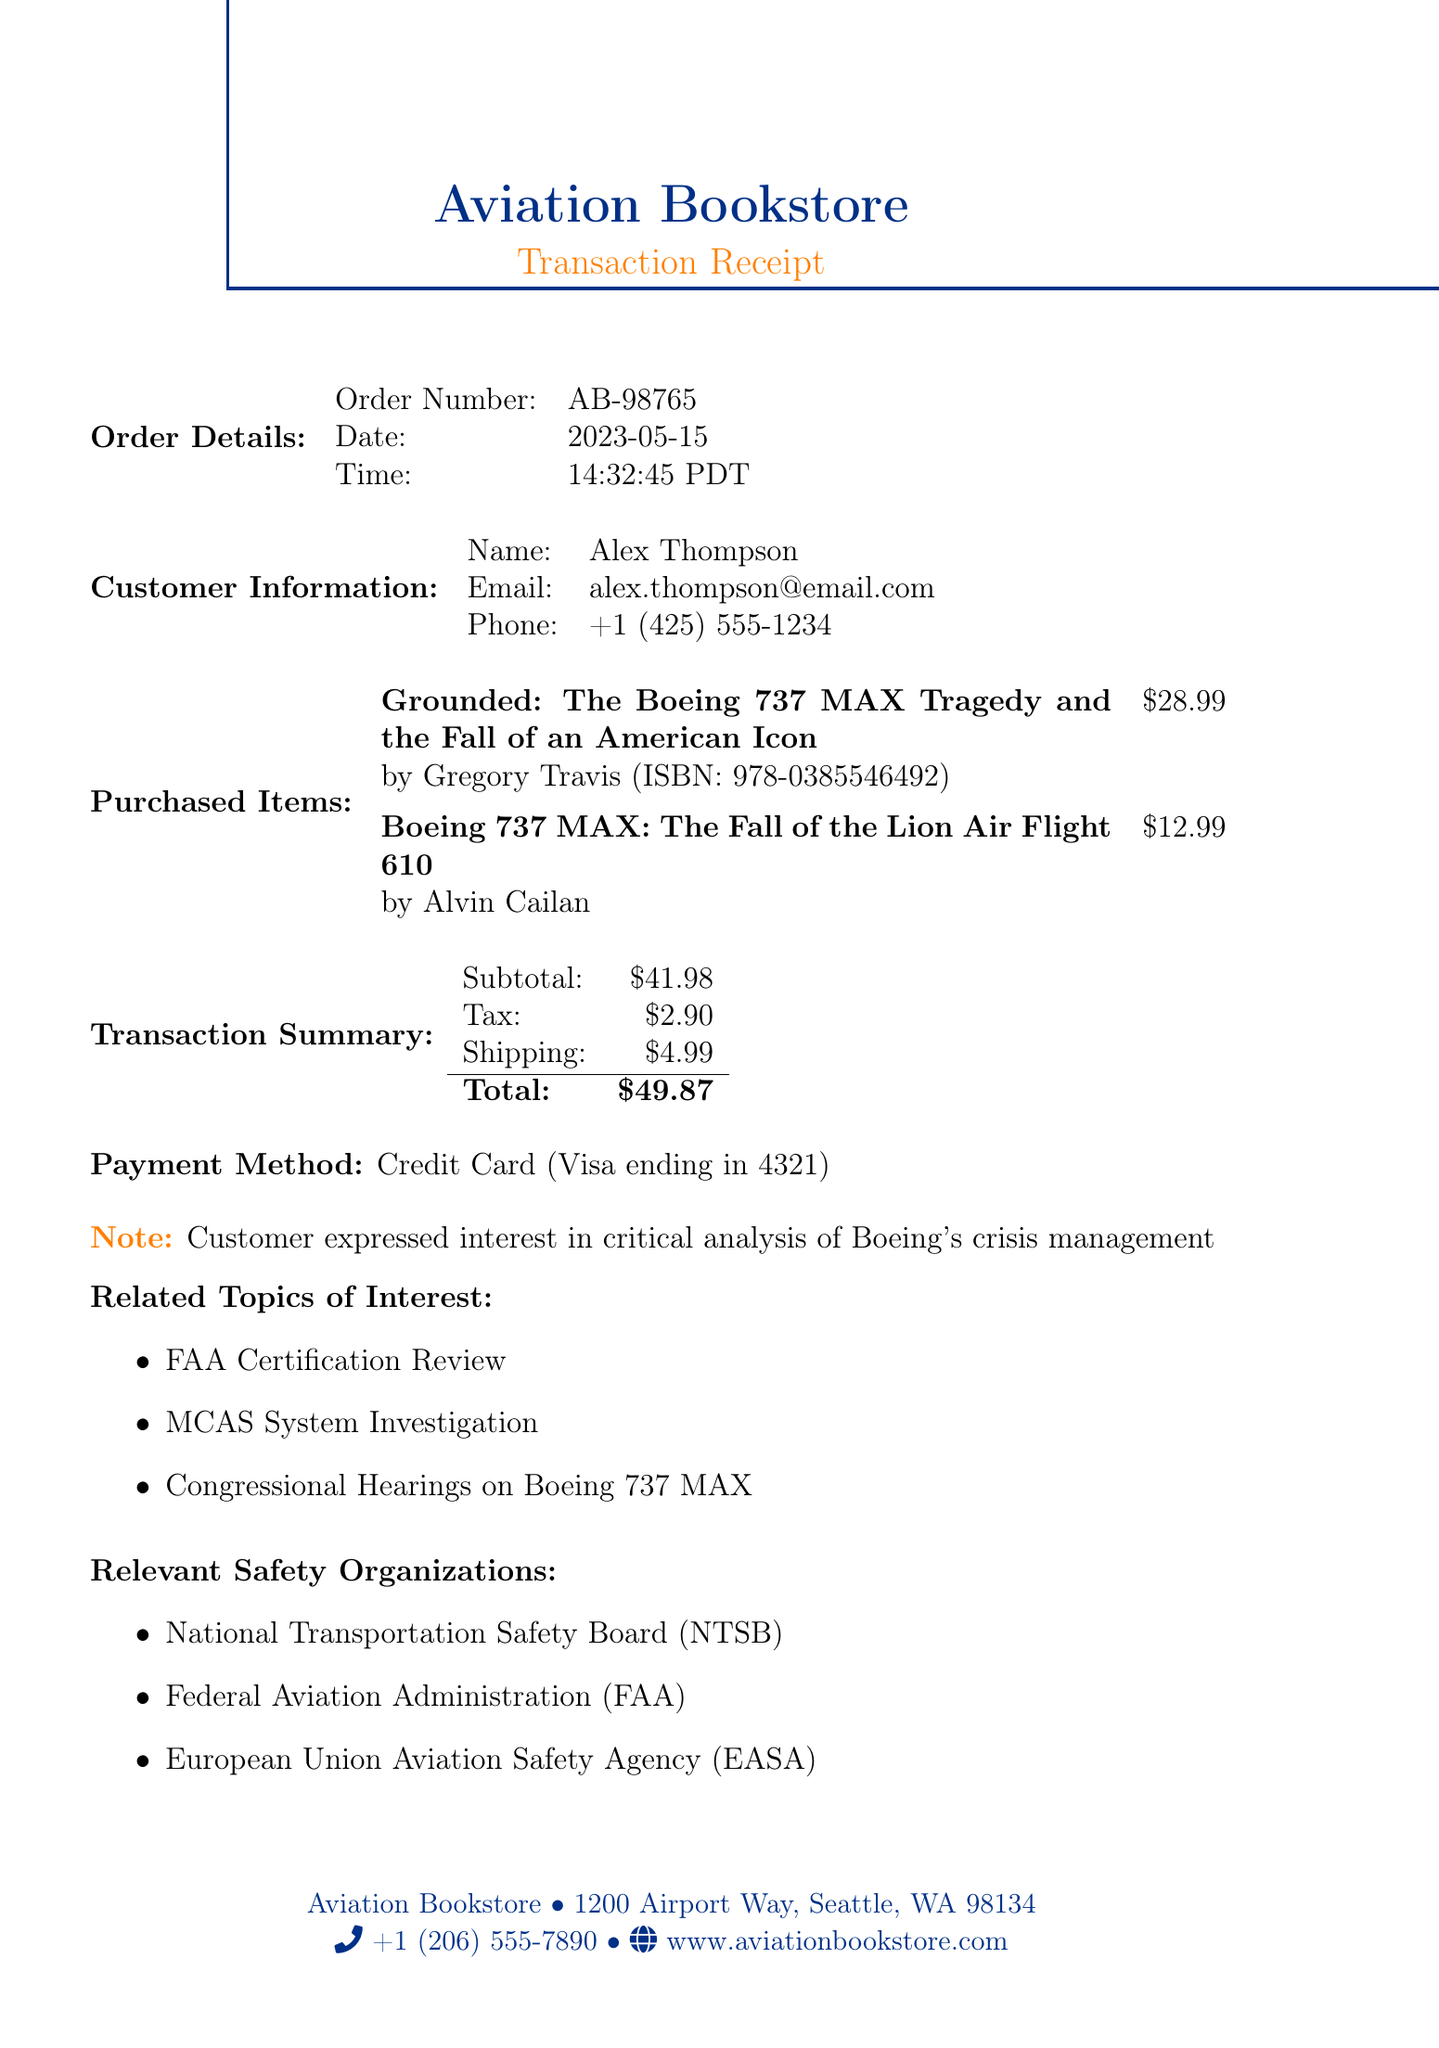What is the title of the purchased book? The title of the purchased book is stated in the document under book details.
Answer: Grounded: The Boeing 737 MAX Tragedy and the Fall of an American Icon Who is the author of the book? The author's name is provided alongside the book title in the document.
Answer: Gregory Travis What is the total amount paid for the transaction? The total amount is clearly listed in the transaction summary of the document.
Answer: $36.88 What is the order number associated with this purchase? The order number is mentioned in the order details section of the document.
Answer: AB-98765 What note did the customer express? The document contains a note section highlighting the customer's interest.
Answer: Customer expressed interest in critical analysis of Boeing's crisis management How much was charged for shipping? The shipping cost is detailed in the transaction summary section of the document.
Answer: $4.99 What was the payment method used for this transaction? The payment method is explicitly stated in the transaction summary of the document.
Answer: Credit Card (Visa ending in 4321) Name one related event mentioned in the document. The document lists several related events that are significant to the context of the purchase.
Answer: FAA Certification Review 